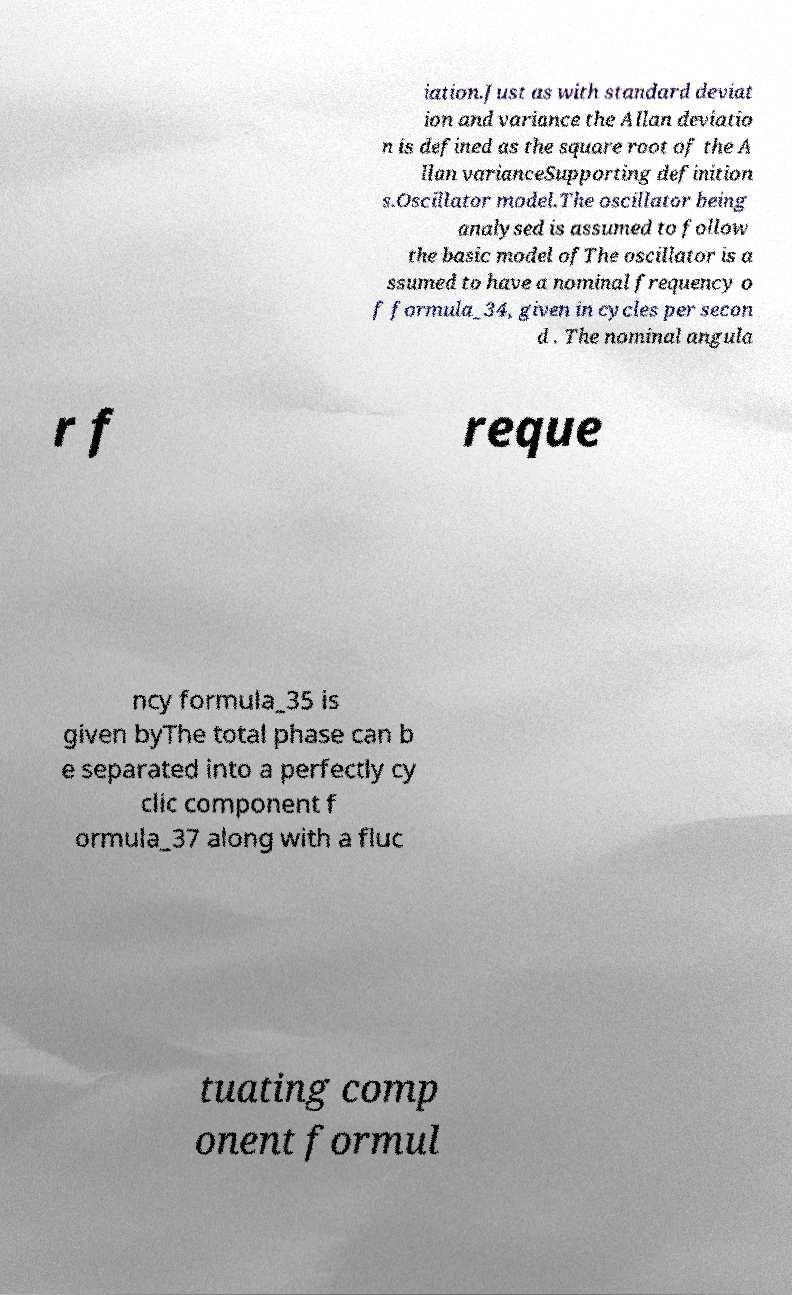Can you accurately transcribe the text from the provided image for me? iation.Just as with standard deviat ion and variance the Allan deviatio n is defined as the square root of the A llan varianceSupporting definition s.Oscillator model.The oscillator being analysed is assumed to follow the basic model ofThe oscillator is a ssumed to have a nominal frequency o f formula_34, given in cycles per secon d . The nominal angula r f reque ncy formula_35 is given byThe total phase can b e separated into a perfectly cy clic component f ormula_37 along with a fluc tuating comp onent formul 